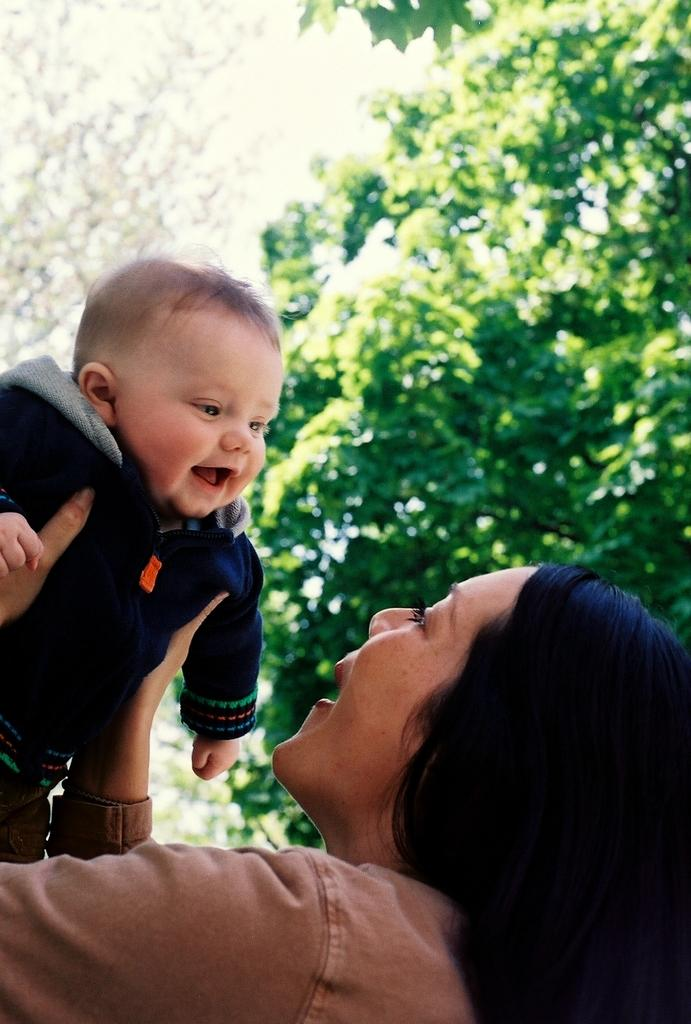Who is the main subject in the image? There is a woman in the image. What is the woman doing in the image? The woman is carrying a baby. How are the woman and the baby interacting in the image? The woman and the baby are looking at each other and smiling. What can be seen in the background of the image? There are trees in the background of the image. What type of steel object is visible in the image? There is no steel object present in the image. What trick is the woman performing with the baby in the image? There is no trick being performed in the image; the woman and the baby are simply looking at each other and smiling. 